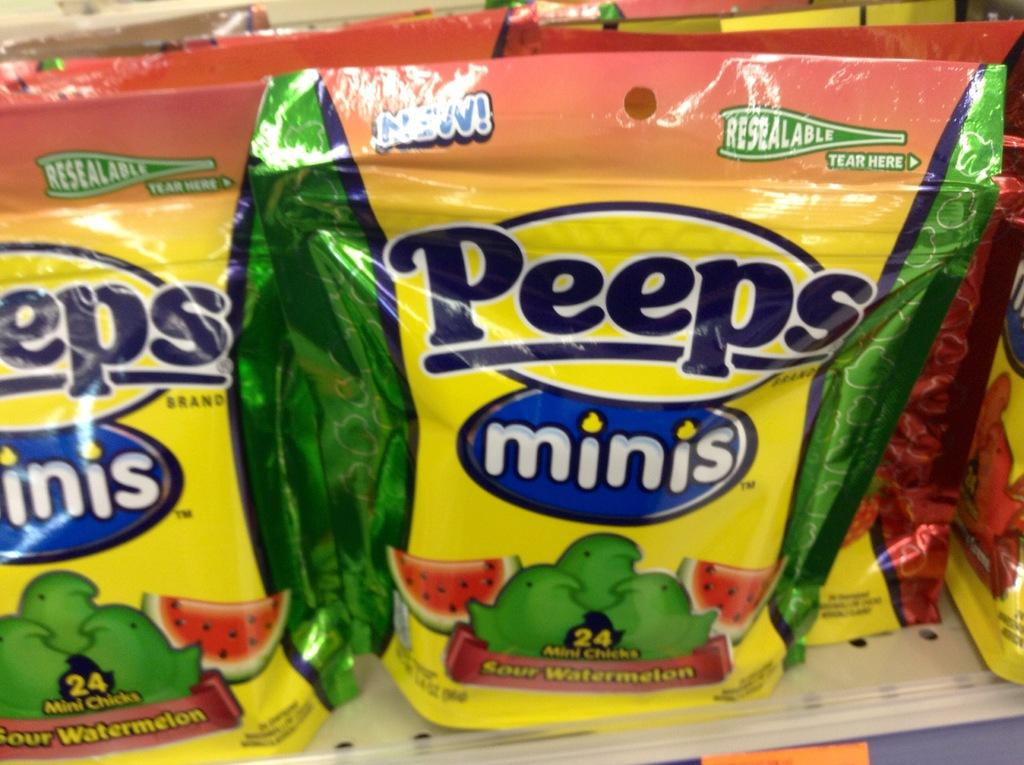What type of items are in the image? There are candy packets in the image. How are the candy packets arranged? The candy packets are arranged in the image. What can be seen on the candy packets? There is writing on the candy packets. What colors are the candy packets? The candy packets are in yellow, green, and orange colors. What type of plastic is used to make the grain in the image? There is no plastic or grain present in the image; it features candy packets in yellow, green, and orange colors with writing on them. 